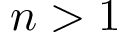Convert formula to latex. <formula><loc_0><loc_0><loc_500><loc_500>n > 1</formula> 